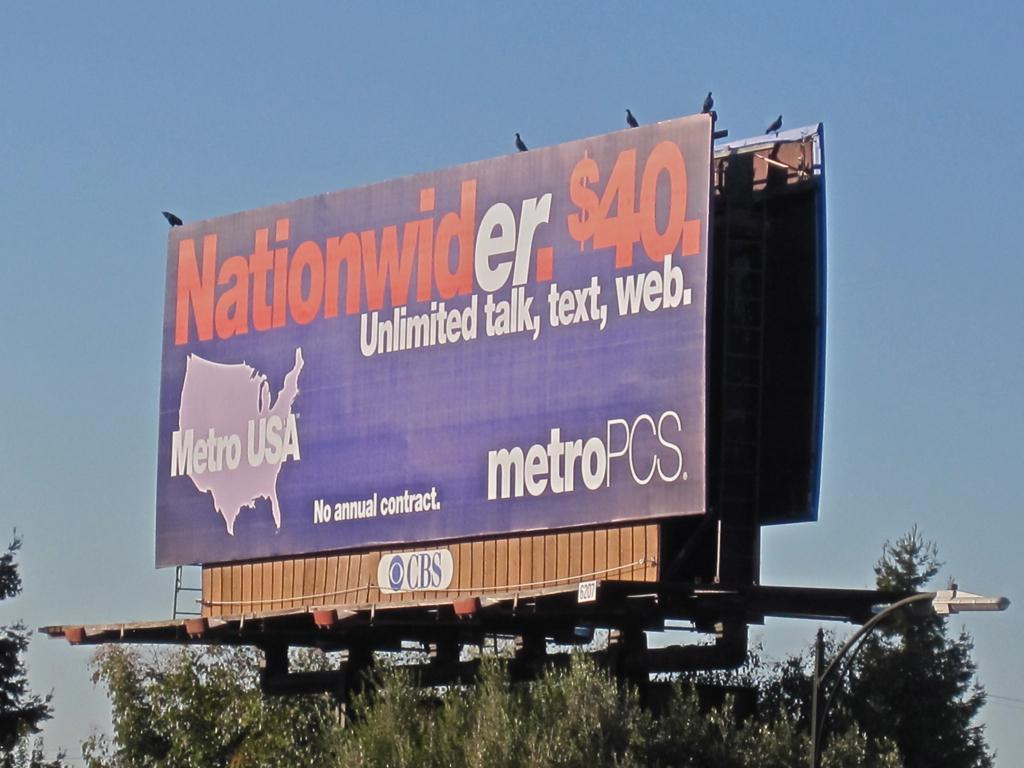Provide a one-sentence caption for the provided image. A billboard sign from Metro PCS USA advertising. 